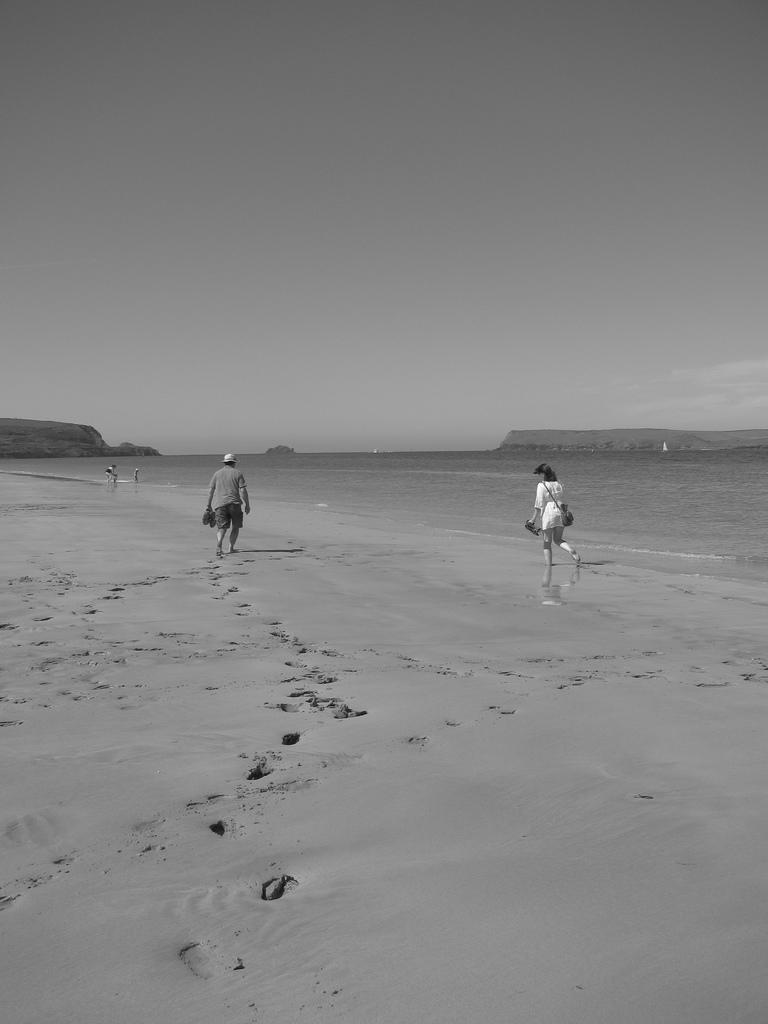What type of terrain is visible in the image? There is a beach with sand in the image. What are the two people in the image doing? Two people are walking on the beach. What can be seen besides the beach in the image? There is a water surface visible in the image, as well as hills in the distance. What part of the natural environment is visible in the image? The sky is visible in the image. What type of rose is growing on the beach in the image? There are no roses present in the image; it features a beach with sand, a water surface, hills, and the sky. 